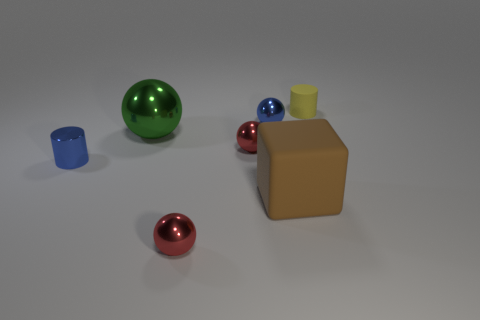Is there a shiny cylinder of the same size as the yellow matte thing?
Keep it short and to the point. Yes. There is a green metal object that is the same size as the brown rubber cube; what shape is it?
Your answer should be very brief. Sphere. Are there any blue metallic things that have the same shape as the large green metallic thing?
Your answer should be compact. Yes. Is the block made of the same material as the cylinder that is in front of the tiny yellow matte cylinder?
Your response must be concise. No. Are there any other objects that have the same color as the small matte thing?
Keep it short and to the point. No. How many other things are there of the same material as the yellow object?
Give a very brief answer. 1. There is a small metallic cylinder; is it the same color as the shiny ball that is behind the large ball?
Your response must be concise. Yes. Are there more red metallic things left of the yellow object than green shiny balls?
Make the answer very short. Yes. There is a small blue thing behind the tiny shiny object that is on the left side of the large green ball; what number of things are right of it?
Your answer should be very brief. 2. There is a blue metal object right of the large metallic ball; is it the same shape as the big green shiny object?
Your answer should be compact. Yes. 